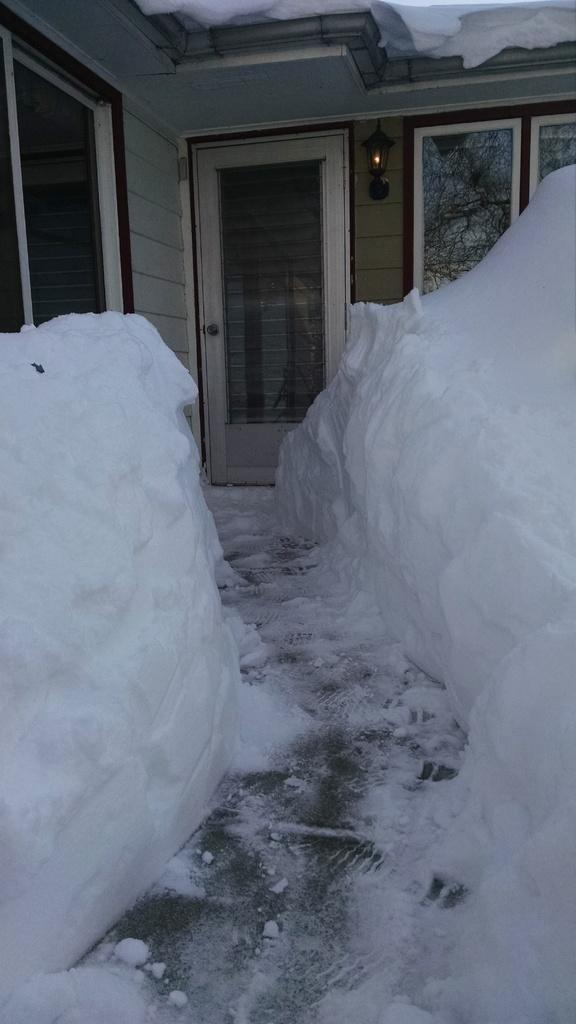What type of structure is visible in the image? There is a wall of a house in the image. What features can be seen on the wall? There are windows, a door, and a wall lamp visible on the wall. What is the weather condition outside the house}? There is snow on the ground outside the door, indicating a snowy weather condition. What type of process is being carried out in the image? There is no process visible in the image. 